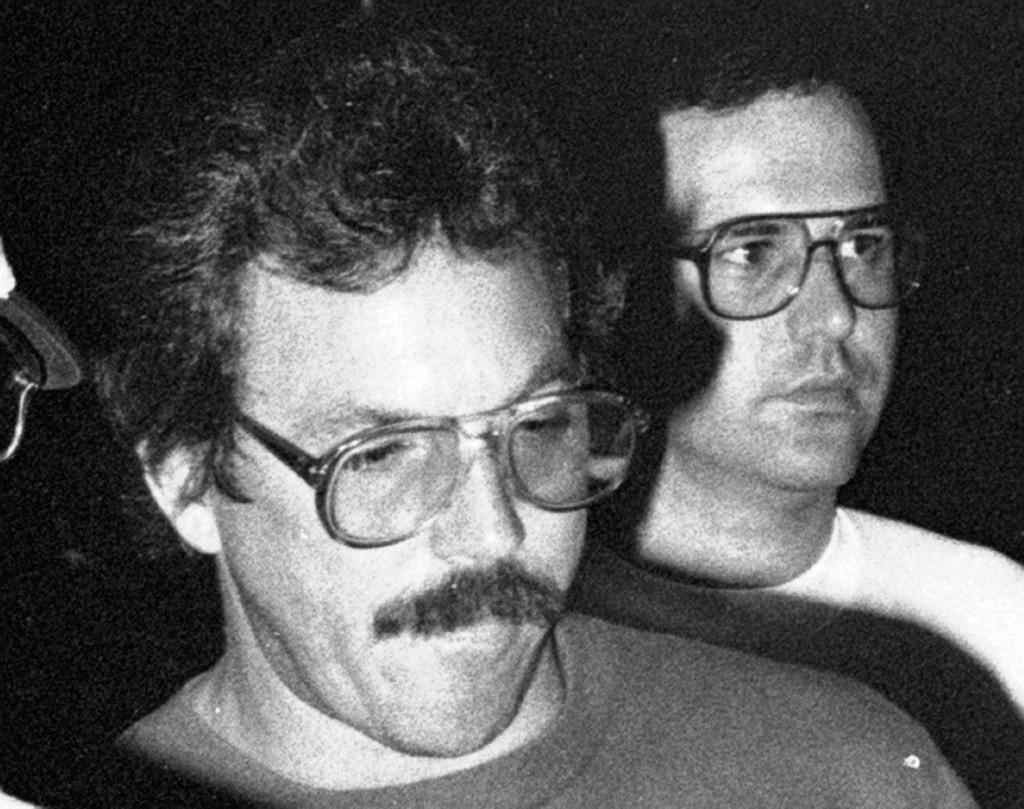How many people are in the image? There are two persons in the image. What are the persons doing in the image? Both persons are standing. What objects can be seen on the left side of the image? There are glasses on the left side of the image. What type of berry is being brushed by one of the persons in the image? There is no berry or brush present in the image. 